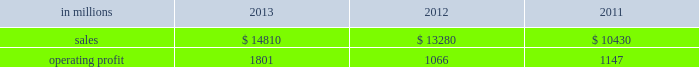Areas exceeding 14.1 million acres ( 5.7 million hectares ) .
Products and brand designations appearing in italics are trademarks of international paper or a related company .
Industry segment results industrial packaging demand for industrial packaging products is closely correlated with non-durable industrial goods production , as well as with demand for processed foods , poultry , meat and agricultural products .
In addition to prices and volumes , major factors affecting the profitability of industrial packaging are raw material and energy costs , freight costs , manufacturing efficiency and product mix .
Industrial packaging net sales and operating profits include the results of the temple-inland packaging operations from the date of acquisition in february 2012 and the results of the brazil packaging business from the date of acquisition in january 2013 .
In addition , due to the acquisition of a majority share of olmuksa international paper sabanci ambalaj sanayi ve ticaret a.s. , ( now called olmuksan international paper or olmuksan ) net sales for our corrugated packaging business in turkey are included in the business segment totals beginning in the first quarter of 2013 and the operating profits reflect a higher ownership percentage than in previous years .
Net sales for 2013 increased 12% ( 12 % ) to $ 14.8 billion compared with $ 13.3 billion in 2012 , and 42% ( 42 % ) compared with $ 10.4 billion in 2011 .
Operating profits were 69% ( 69 % ) higher in 2013 than in 2012 and 57% ( 57 % ) higher than in 2011 .
Excluding costs associated with the acquisition and integration of temple-inland , the divestiture of three containerboard mills and other special items , operating profits in 2013 were 36% ( 36 % ) higher than in 2012 and 59% ( 59 % ) higher than in 2011 .
Benefits from the net impact of higher average sales price realizations and an unfavorable mix ( $ 749 million ) were offset by lower sales volumes ( $ 73 million ) , higher operating costs ( $ 64 million ) , higher maintenance outage costs ( $ 16 million ) and higher input costs ( $ 102 million ) .
Additionally , operating profits in 2013 include costs of $ 62 million associated with the integration of temple-inland , a gain of $ 13 million related to a bargain purchase adjustment on the acquisition of a majority share of our operations in turkey , and a net gain of $ 1 million for other items , while operating profits in 2012 included costs of $ 184 million associated with the acquisition and integration of temple-inland , mill divestiture costs of $ 91 million , costs associated with the restructuring of our european packaging business of $ 17 million and a $ 3 million gain for other items .
Industrial packaging .
North american industrial packaging net sales were $ 12.5 billion in 2013 compared with $ 11.6 billion in 2012 and $ 8.6 billion in 2011 .
Operating profits in 2013 were $ 1.8 billion ( both including and excluding costs associated with the integration of temple-inland and other special items ) compared with $ 1.0 billion ( $ 1.3 billion excluding costs associated with the acquisition and integration of temple-inland and mill divestiture costs ) in 2012 and $ 1.1 billion ( both including and excluding costs associated with signing an agreement to acquire temple-inland ) in 2011 .
Sales volumes decreased in 2013 compared with 2012 reflecting flat demand for boxes and the impact of commercial decisions .
Average sales price realizations were significantly higher mainly due to the realization of price increases for domestic containerboard and boxes .
Input costs were higher for wood , energy and recycled fiber .
Freight costs also increased .
Planned maintenance downtime costs were higher than in 2012 .
Manufacturing operating costs decreased , but were offset by inflation and higher overhead and distribution costs .
The business took about 850000 tons of total downtime in 2013 of which about 450000 were market- related and 400000 were maintenance downtime .
In 2012 , the business took about 945000 tons of total downtime of which about 580000 were market-related and about 365000 were maintenance downtime .
Operating profits in 2013 included $ 62 million of costs associated with the integration of temple-inland .
Operating profits in 2012 included $ 184 million of costs associated with the acquisition and integration of temple-inland and $ 91 million of costs associated with the divestiture of three containerboard mills .
Looking ahead to 2014 , compared with the fourth quarter of 2013 , sales volumes in the first quarter are expected to increase for boxes due to a higher number of shipping days offset by the impact from the severe winter weather events impacting much of the u.s .
Input costs are expected to be higher for energy , recycled fiber , wood and starch .
Planned maintenance downtime spending is expected to be about $ 51 million higher with outages scheduled at six mills compared with four mills in the 2013 fourth quarter .
Manufacturing operating costs are expected to be lower .
However , operating profits will be negatively impacted by the adverse winter weather in the first quarter of 2014 .
Emea industrial packaging net sales in 2013 include the sales of our packaging operations in turkey which are now fully consolidated .
Net sales were $ 1.3 billion in 2013 compared with $ 1.0 billion in 2012 and $ 1.1 billion in 2011 .
Operating profits in 2013 were $ 43 million ( $ 32 .
What percentage of industrial packaging sales where represented by north american industrial packaging net sales in 2012? 
Computations: ((11.6 * 1000) / 13280)
Answer: 0.87349. 